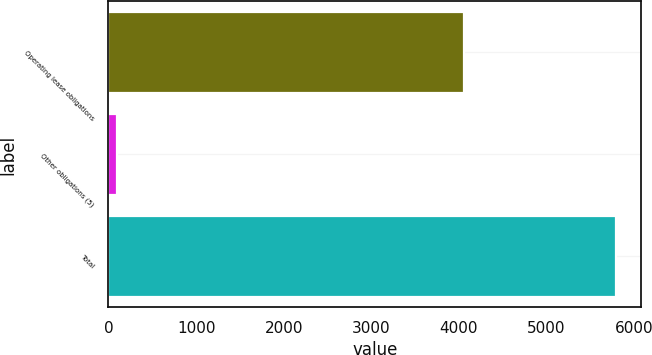<chart> <loc_0><loc_0><loc_500><loc_500><bar_chart><fcel>Operating lease obligations<fcel>Other obligations (5)<fcel>Total<nl><fcel>4060.2<fcel>94.9<fcel>5788.1<nl></chart> 